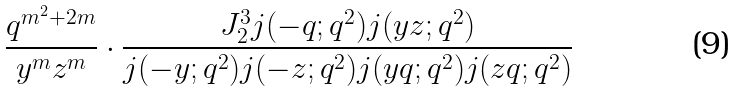<formula> <loc_0><loc_0><loc_500><loc_500>\frac { q ^ { m ^ { 2 } + 2 m } } { y ^ { m } z ^ { m } } \cdot \frac { J _ { 2 } ^ { 3 } j ( - q ; q ^ { 2 } ) j ( y z ; q ^ { 2 } ) } { j ( - y ; q ^ { 2 } ) j ( - z ; q ^ { 2 } ) j ( y q ; q ^ { 2 } ) j ( z q ; q ^ { 2 } ) }</formula> 